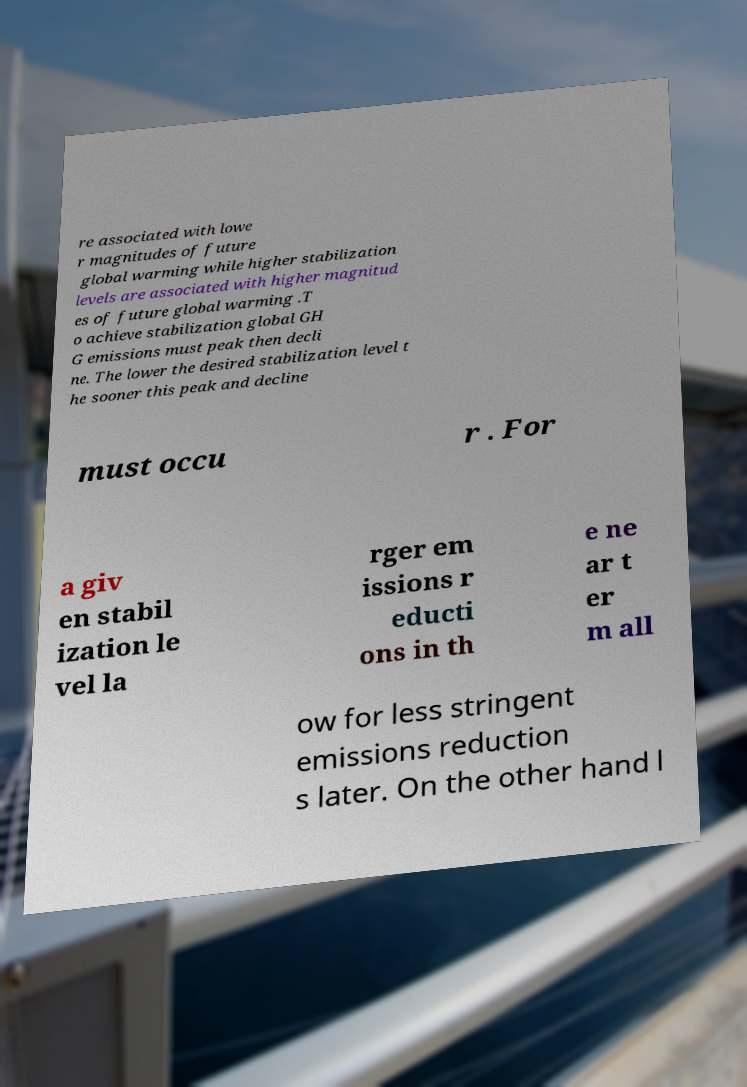Can you read and provide the text displayed in the image?This photo seems to have some interesting text. Can you extract and type it out for me? re associated with lowe r magnitudes of future global warming while higher stabilization levels are associated with higher magnitud es of future global warming .T o achieve stabilization global GH G emissions must peak then decli ne. The lower the desired stabilization level t he sooner this peak and decline must occu r . For a giv en stabil ization le vel la rger em issions r educti ons in th e ne ar t er m all ow for less stringent emissions reduction s later. On the other hand l 